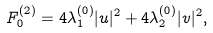Convert formula to latex. <formula><loc_0><loc_0><loc_500><loc_500>F _ { 0 } ^ { ( 2 ) } = 4 \lambda _ { 1 } ^ { ( 0 ) } | u | ^ { 2 } + 4 \lambda _ { 2 } ^ { ( 0 ) } | v | ^ { 2 } ,</formula> 